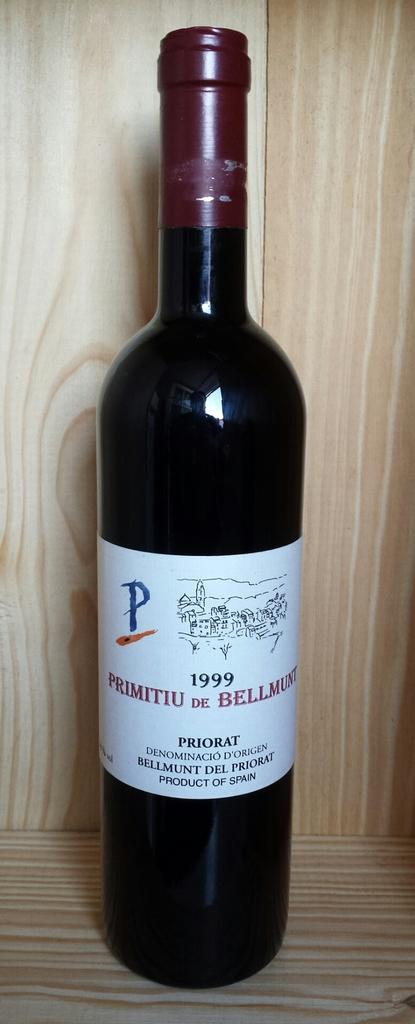<image>
Write a terse but informative summary of the picture. Black bottle with a white label that has the year 1999 on it. 